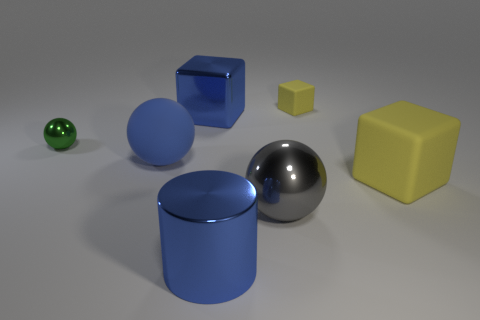What number of things are either big blue shiny objects in front of the green metal object or small red metal blocks?
Provide a succinct answer. 1. Are there any small blue matte cylinders?
Offer a terse response. No. There is a large cube to the right of the cylinder; what is it made of?
Your response must be concise. Rubber. What is the material of the small object that is the same color as the big matte block?
Offer a terse response. Rubber. What number of small objects are either shiny cylinders or yellow rubber cubes?
Provide a succinct answer. 1. The large rubber ball is what color?
Your answer should be very brief. Blue. Is there a blue matte object that is in front of the large matte object that is on the left side of the big cylinder?
Offer a terse response. No. Are there fewer big gray spheres that are to the left of the blue shiny block than small cyan cubes?
Provide a short and direct response. No. Do the object that is in front of the gray sphere and the green ball have the same material?
Make the answer very short. Yes. What is the color of the sphere that is the same material as the green thing?
Provide a short and direct response. Gray. 